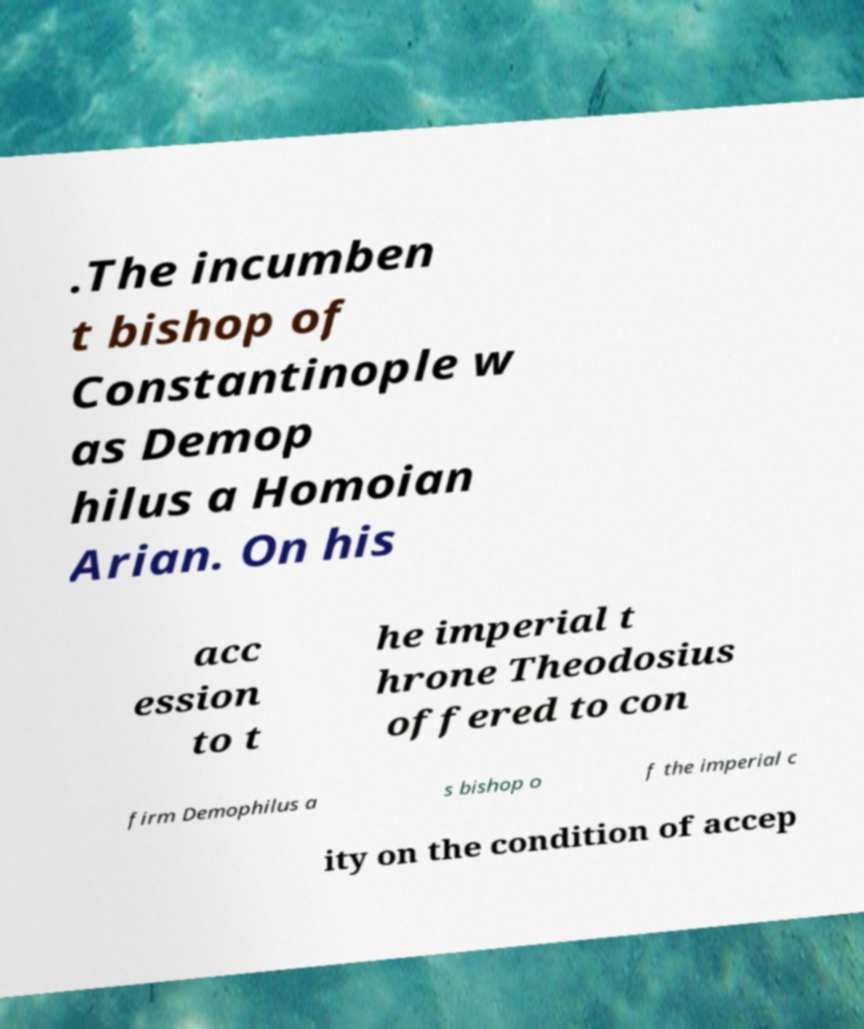Can you accurately transcribe the text from the provided image for me? .The incumben t bishop of Constantinople w as Demop hilus a Homoian Arian. On his acc ession to t he imperial t hrone Theodosius offered to con firm Demophilus a s bishop o f the imperial c ity on the condition of accep 